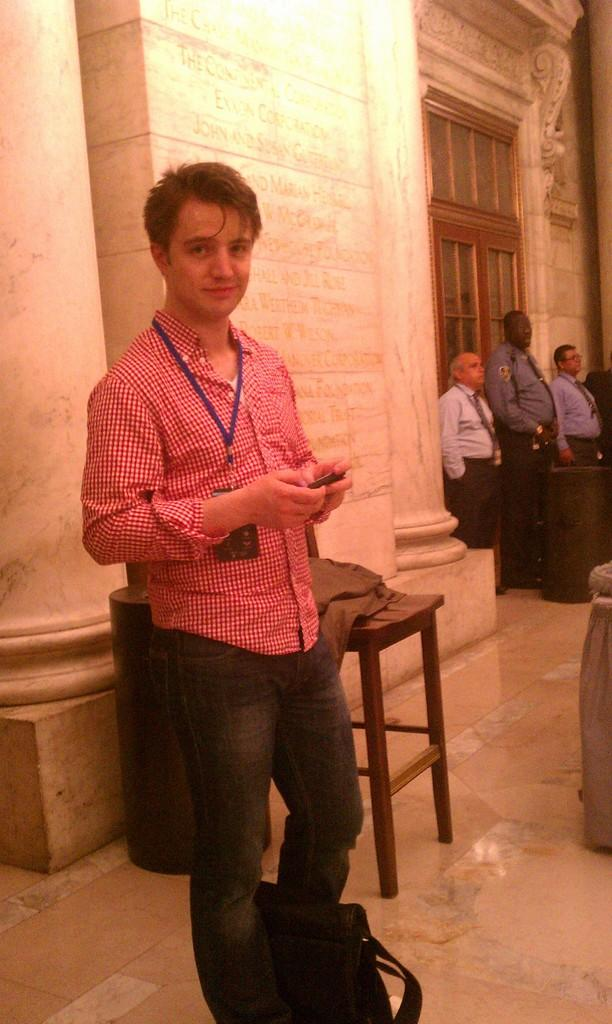What is the man in the image doing? The man is standing in the image and holding a mobile phone. What object is located between the man's legs? There is a bag between the man's legs. What can be seen in the background of the image? There are people standing in the background, as well as a wall and a door. What is the purpose of the mother in the image? There is no mention of a mother in the image, so we cannot answer a question about her purpose. 